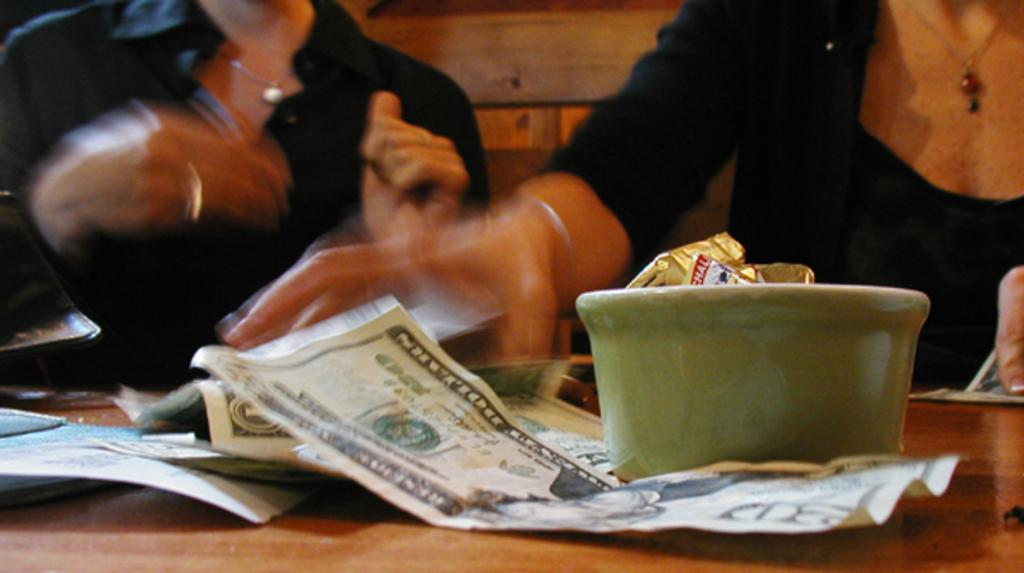What is the main object in the image? There is a table in the image. What is placed on the table? There are dollars and a cup on the table. How many people are in the image? There are two persons standing in front of the table. What can be seen in the background of the image? There is a wooden wall in the background of the image. What type of fruit is being used to paint the snow in the image? There is no fruit, snow, or painting activity present in the image. 